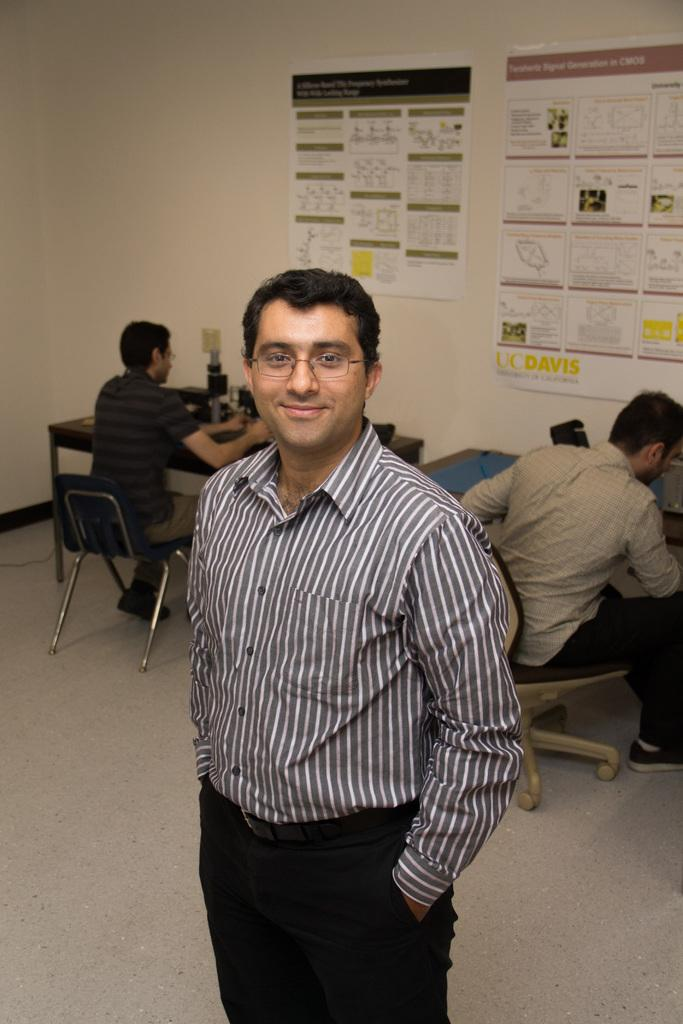Where was the image taken? The image was taken in a room. What are the people in the image doing? There is a group of people sitting on chairs. Can you describe the man in the image? There is a man in a checkered shirt standing on the floor. What can be seen behind the people in the image? The background of the people is a wall with papers. What type of fowl can be seen on the tray in the image? There is no tray or fowl present in the image. 